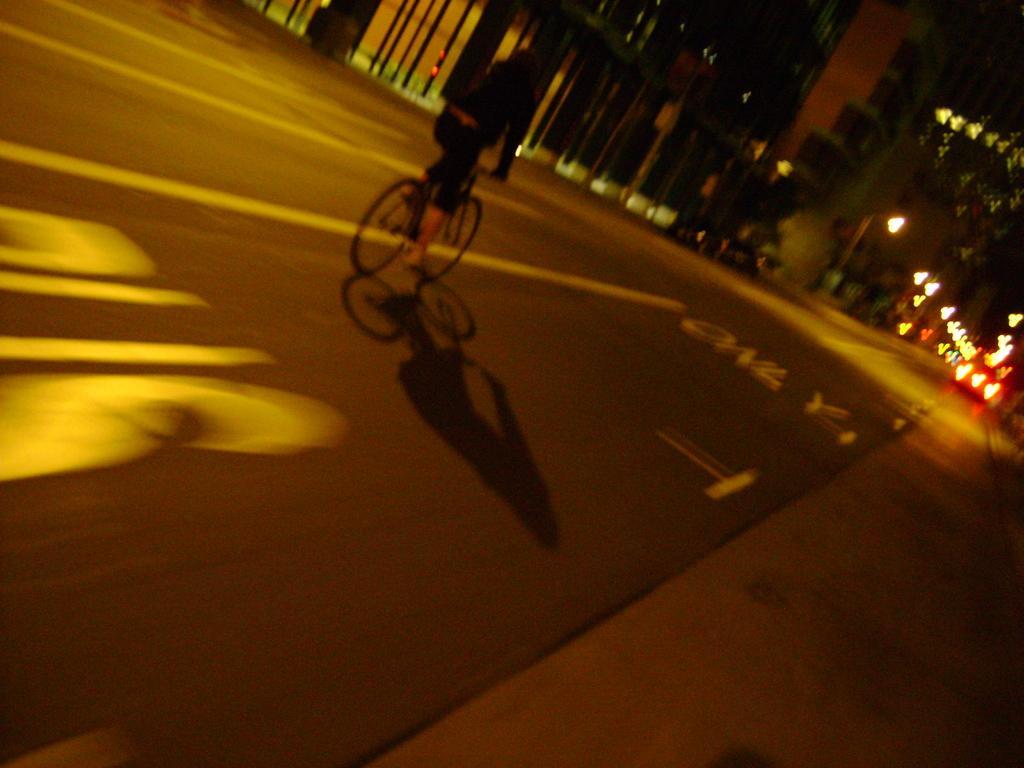Can you describe this image briefly? In this image, we can see a person riding the bicycle. We can see the ground. We can also see some lights and a few objects at the top. 